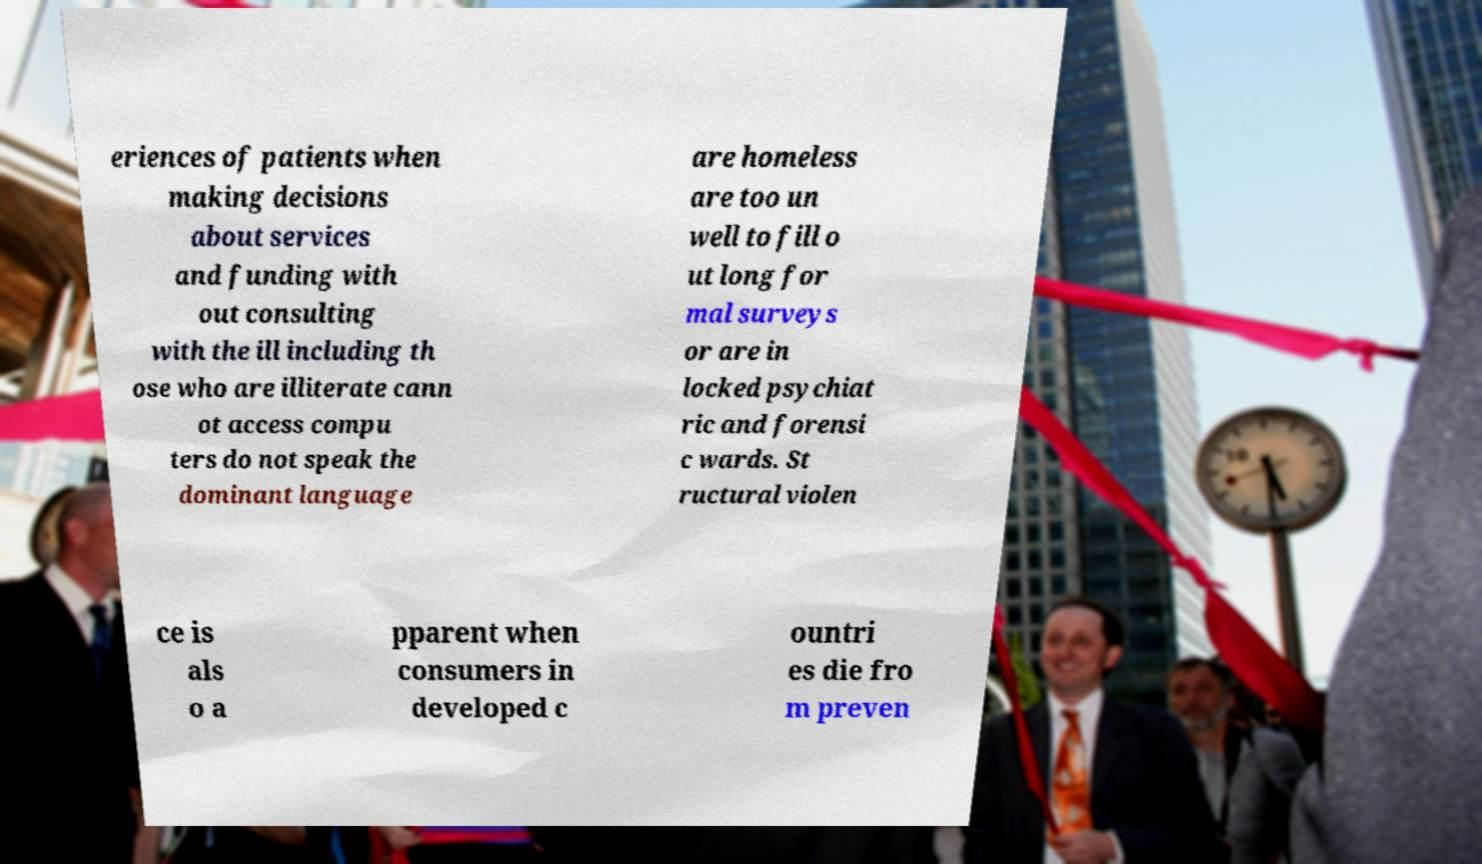I need the written content from this picture converted into text. Can you do that? eriences of patients when making decisions about services and funding with out consulting with the ill including th ose who are illiterate cann ot access compu ters do not speak the dominant language are homeless are too un well to fill o ut long for mal surveys or are in locked psychiat ric and forensi c wards. St ructural violen ce is als o a pparent when consumers in developed c ountri es die fro m preven 